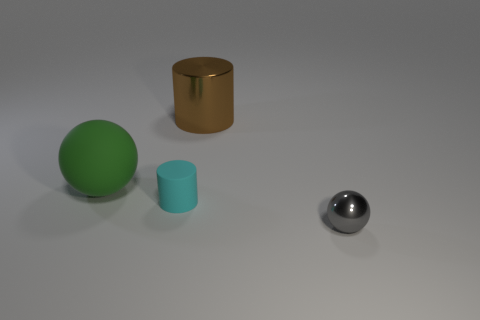Can you describe the colors of the objects in the image? Certainly! There are four objects in the image, each with a distinct color. Starting from the left, there's a large green sphere, a gold cylinder, a smaller teal cylinder, and a small, shiny silver sphere to the right. 